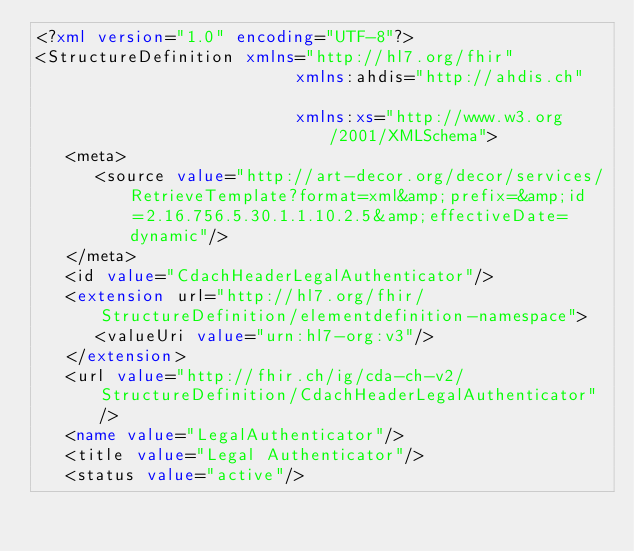<code> <loc_0><loc_0><loc_500><loc_500><_XML_><?xml version="1.0" encoding="UTF-8"?>
<StructureDefinition xmlns="http://hl7.org/fhir"
                          xmlns:ahdis="http://ahdis.ch"
                         
                          xmlns:xs="http://www.w3.org/2001/XMLSchema">
   <meta>
      <source value="http://art-decor.org/decor/services/RetrieveTemplate?format=xml&amp;prefix=&amp;id=2.16.756.5.30.1.1.10.2.5&amp;effectiveDate=dynamic"/>
   </meta>
   <id value="CdachHeaderLegalAuthenticator"/>
   <extension url="http://hl7.org/fhir/StructureDefinition/elementdefinition-namespace">
      <valueUri value="urn:hl7-org:v3"/>
   </extension>
   <url value="http://fhir.ch/ig/cda-ch-v2/StructureDefinition/CdachHeaderLegalAuthenticator"/>
   <name value="LegalAuthenticator"/>
   <title value="Legal Authenticator"/>
   <status value="active"/></code> 